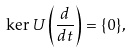<formula> <loc_0><loc_0><loc_500><loc_500>\ker U \left ( \frac { d } { d t } \right ) = \{ 0 \} ,</formula> 